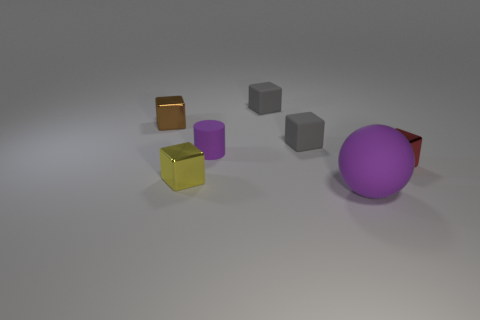What shape is the shiny object behind the small matte cylinder?
Your answer should be very brief. Cube. There is a purple matte object that is behind the purple rubber object on the right side of the purple object on the left side of the big rubber thing; how big is it?
Your answer should be very brief. Small. Is the tiny purple thing the same shape as the brown metal object?
Give a very brief answer. No. There is a shiny object that is both in front of the rubber cylinder and left of the large matte thing; what is its size?
Offer a very short reply. Small. What material is the tiny yellow thing that is the same shape as the small red metallic thing?
Your response must be concise. Metal. The purple thing on the right side of the purple rubber thing that is to the left of the big rubber ball is made of what material?
Keep it short and to the point. Rubber. Do the tiny brown object and the purple matte object right of the small cylinder have the same shape?
Offer a very short reply. No. What number of matte things are tiny brown cubes or balls?
Your answer should be very brief. 1. There is a thing that is in front of the small thing that is in front of the tiny metallic cube right of the large matte object; what color is it?
Provide a short and direct response. Purple. How many other things are there of the same material as the tiny red thing?
Your answer should be very brief. 2. 